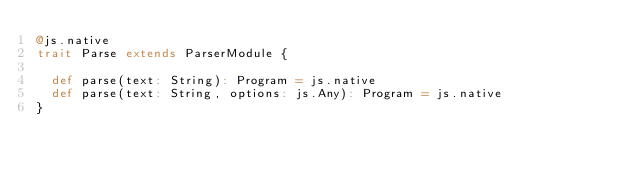Convert code to text. <code><loc_0><loc_0><loc_500><loc_500><_Scala_>@js.native
trait Parse extends ParserModule {
  
  def parse(text: String): Program = js.native
  def parse(text: String, options: js.Any): Program = js.native
}
</code> 